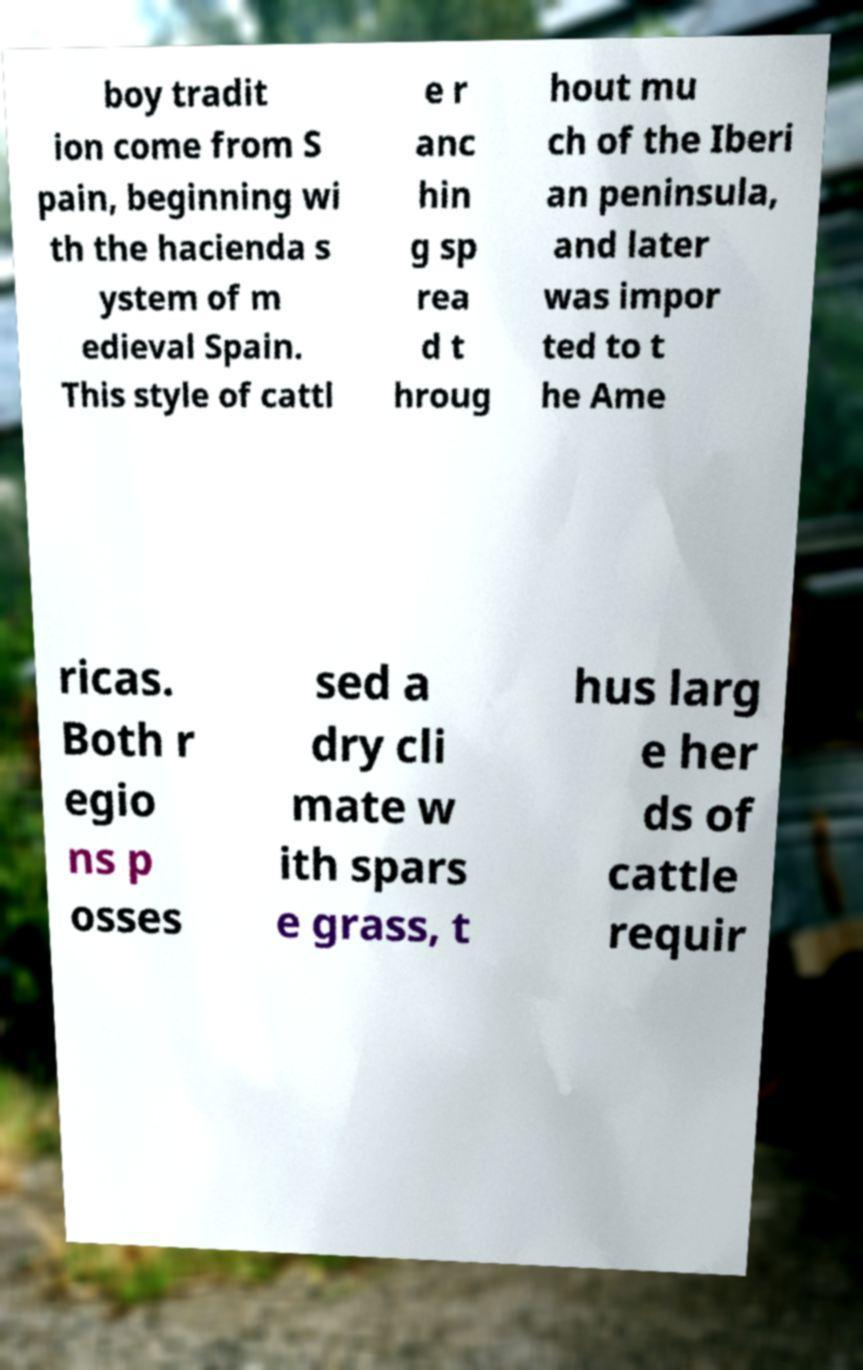Can you accurately transcribe the text from the provided image for me? boy tradit ion come from S pain, beginning wi th the hacienda s ystem of m edieval Spain. This style of cattl e r anc hin g sp rea d t hroug hout mu ch of the Iberi an peninsula, and later was impor ted to t he Ame ricas. Both r egio ns p osses sed a dry cli mate w ith spars e grass, t hus larg e her ds of cattle requir 